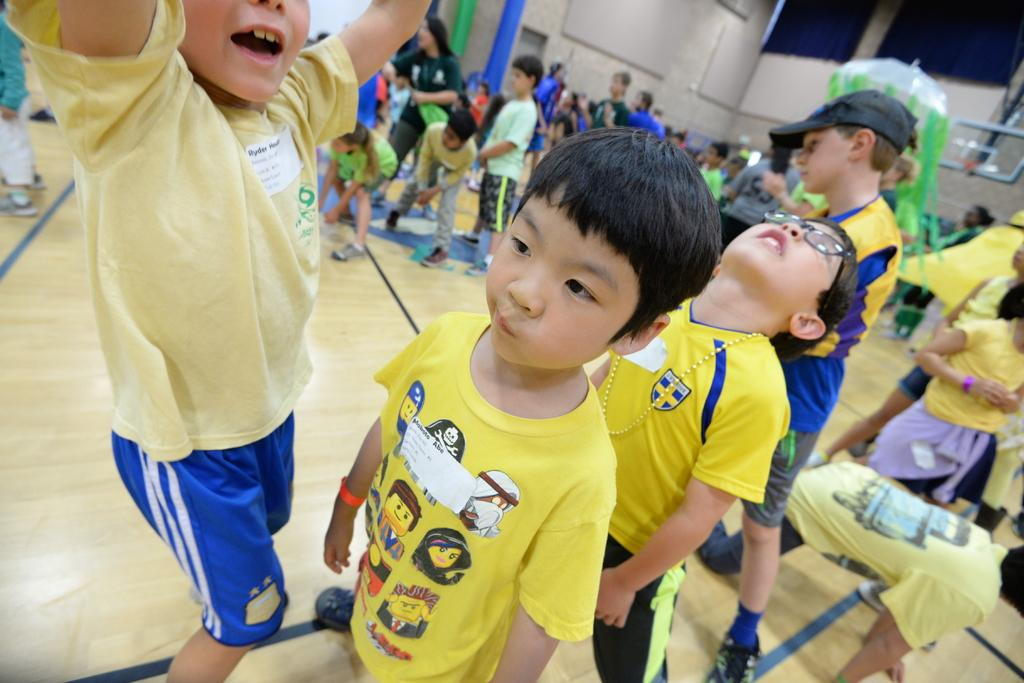How many boys are in the foreground of the image? There are four boys standing in the foreground of the image. What is the surface the boys are standing on? The boys are standing on the floor. What can be seen in the background of the image? There are persons and pipes visible in the background of the image, as well as a wall. What type of badge is being handed out at the meeting in the image? There is no meeting or badge present in the image; it features four boys standing in the foreground and persons, pipes, and a wall in the background. 